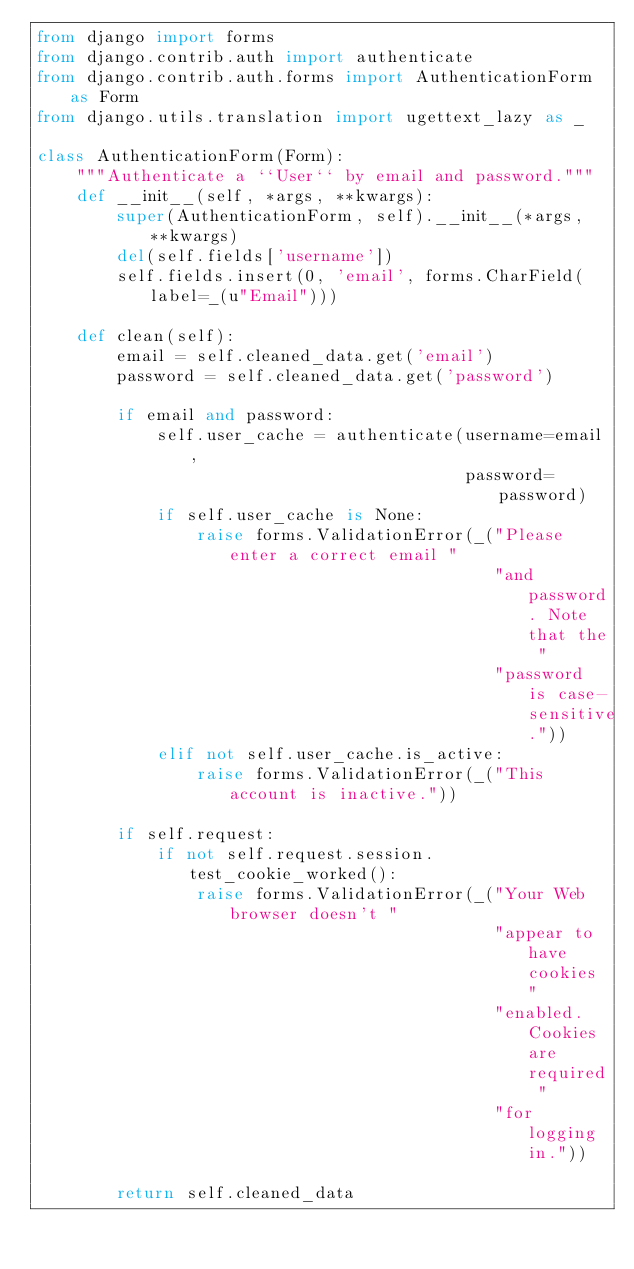<code> <loc_0><loc_0><loc_500><loc_500><_Python_>from django import forms
from django.contrib.auth import authenticate
from django.contrib.auth.forms import AuthenticationForm as Form
from django.utils.translation import ugettext_lazy as _

class AuthenticationForm(Form):
    """Authenticate a ``User`` by email and password."""
    def __init__(self, *args, **kwargs):
        super(AuthenticationForm, self).__init__(*args, **kwargs)
        del(self.fields['username'])
        self.fields.insert(0, 'email', forms.CharField(label=_(u"Email")))

    def clean(self):
        email = self.cleaned_data.get('email')
        password = self.cleaned_data.get('password')

        if email and password:
            self.user_cache = authenticate(username=email,
                                           password=password)
            if self.user_cache is None:
                raise forms.ValidationError(_("Please enter a correct email "
                                              "and password. Note that the "
                                              "password is case-sensitive."))
            elif not self.user_cache.is_active:
                raise forms.ValidationError(_("This account is inactive."))

        if self.request:
            if not self.request.session.test_cookie_worked():
                raise forms.ValidationError(_("Your Web browser doesn't "
                                              "appear to have cookies "
                                              "enabled. Cookies are required "
                                              "for logging in."))

        return self.cleaned_data
</code> 